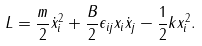Convert formula to latex. <formula><loc_0><loc_0><loc_500><loc_500>L = \frac { m } { 2 } \dot { x } _ { i } ^ { 2 } + \frac { B } { 2 } \epsilon _ { i j } x _ { i } \dot { x } _ { j } - \frac { 1 } { 2 } k x _ { i } ^ { 2 } .</formula> 